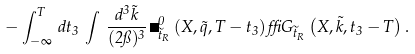Convert formula to latex. <formula><loc_0><loc_0><loc_500><loc_500>- \int _ { - \infty } ^ { T } \, d t _ { 3 } \, \int \, \frac { d ^ { 3 } \vec { k } } { ( 2 \pi ) ^ { 3 } } \, \Sigma ^ { 0 } _ { \widetilde { t } _ { R } } \left ( X , \vec { q } , T - t _ { 3 } \right ) \delta G _ { \widetilde { t } _ { R } } \left ( X , \vec { k } , t _ { 3 } - T \right ) .</formula> 